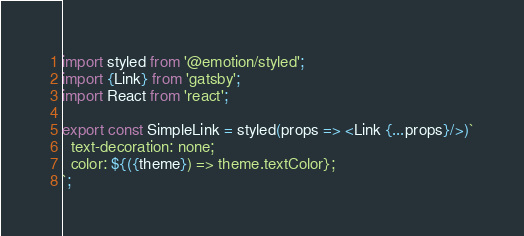Convert code to text. <code><loc_0><loc_0><loc_500><loc_500><_JavaScript_>import styled from '@emotion/styled';
import {Link} from 'gatsby';
import React from 'react';

export const SimpleLink = styled(props => <Link {...props}/>)`
  text-decoration: none;
  color: ${({theme}) => theme.textColor};
`;
</code> 